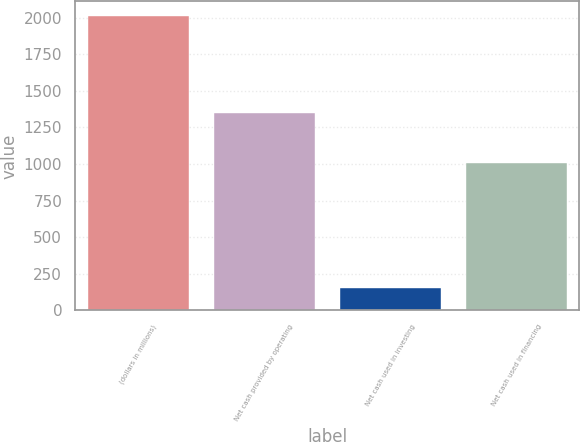<chart> <loc_0><loc_0><loc_500><loc_500><bar_chart><fcel>(dollars in millions)<fcel>Net cash provided by operating<fcel>Net cash used in investing<fcel>Net cash used in financing<nl><fcel>2011<fcel>1346.3<fcel>153.6<fcel>1005.6<nl></chart> 